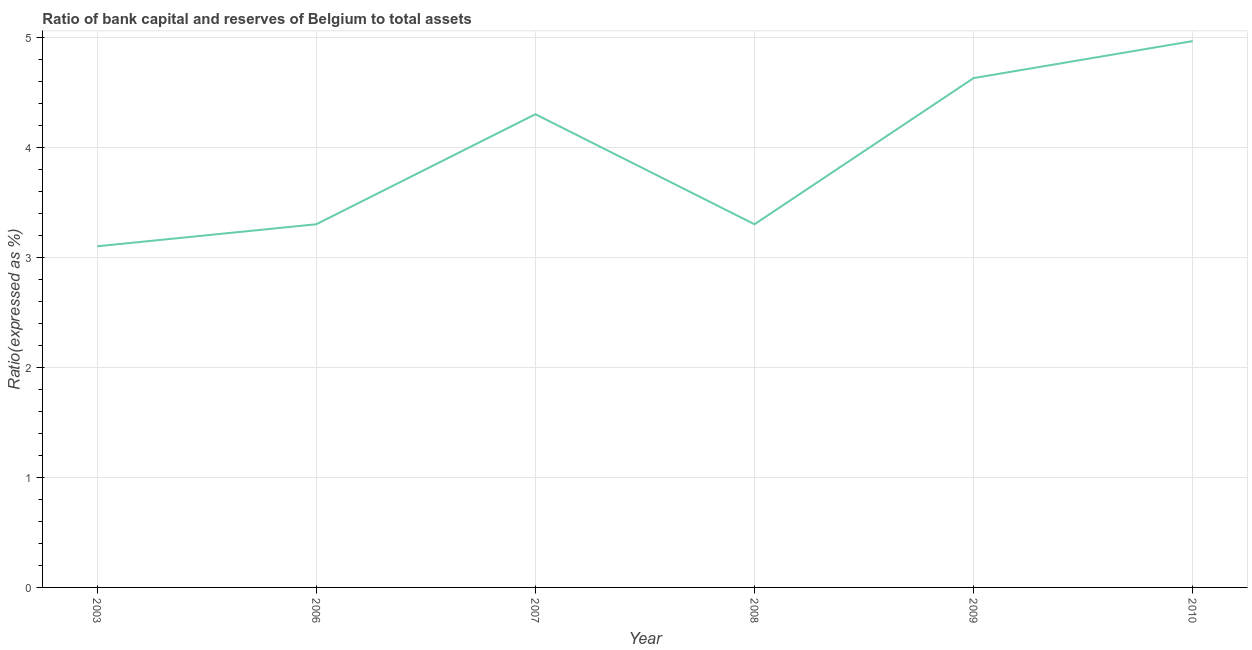Across all years, what is the maximum bank capital to assets ratio?
Offer a terse response. 4.96. Across all years, what is the minimum bank capital to assets ratio?
Your response must be concise. 3.1. What is the sum of the bank capital to assets ratio?
Offer a very short reply. 23.59. What is the difference between the bank capital to assets ratio in 2006 and 2008?
Make the answer very short. 0. What is the average bank capital to assets ratio per year?
Keep it short and to the point. 3.93. What is the median bank capital to assets ratio?
Your answer should be very brief. 3.8. In how many years, is the bank capital to assets ratio greater than 1.6 %?
Your answer should be compact. 6. What is the ratio of the bank capital to assets ratio in 2008 to that in 2010?
Your answer should be compact. 0.66. Is the bank capital to assets ratio in 2003 less than that in 2009?
Keep it short and to the point. Yes. What is the difference between the highest and the second highest bank capital to assets ratio?
Provide a succinct answer. 0.34. What is the difference between the highest and the lowest bank capital to assets ratio?
Make the answer very short. 1.86. Does the bank capital to assets ratio monotonically increase over the years?
Offer a very short reply. No. Does the graph contain any zero values?
Keep it short and to the point. No. Does the graph contain grids?
Make the answer very short. Yes. What is the title of the graph?
Your answer should be very brief. Ratio of bank capital and reserves of Belgium to total assets. What is the label or title of the Y-axis?
Ensure brevity in your answer.  Ratio(expressed as %). What is the Ratio(expressed as %) in 2008?
Keep it short and to the point. 3.3. What is the Ratio(expressed as %) in 2009?
Provide a succinct answer. 4.63. What is the Ratio(expressed as %) of 2010?
Offer a terse response. 4.96. What is the difference between the Ratio(expressed as %) in 2003 and 2006?
Ensure brevity in your answer.  -0.2. What is the difference between the Ratio(expressed as %) in 2003 and 2007?
Your answer should be compact. -1.2. What is the difference between the Ratio(expressed as %) in 2003 and 2009?
Provide a short and direct response. -1.53. What is the difference between the Ratio(expressed as %) in 2003 and 2010?
Make the answer very short. -1.86. What is the difference between the Ratio(expressed as %) in 2006 and 2007?
Your response must be concise. -1. What is the difference between the Ratio(expressed as %) in 2006 and 2009?
Keep it short and to the point. -1.33. What is the difference between the Ratio(expressed as %) in 2006 and 2010?
Your answer should be compact. -1.66. What is the difference between the Ratio(expressed as %) in 2007 and 2009?
Provide a short and direct response. -0.33. What is the difference between the Ratio(expressed as %) in 2007 and 2010?
Your answer should be compact. -0.66. What is the difference between the Ratio(expressed as %) in 2008 and 2009?
Keep it short and to the point. -1.33. What is the difference between the Ratio(expressed as %) in 2008 and 2010?
Offer a terse response. -1.66. What is the difference between the Ratio(expressed as %) in 2009 and 2010?
Provide a succinct answer. -0.34. What is the ratio of the Ratio(expressed as %) in 2003 to that in 2006?
Ensure brevity in your answer.  0.94. What is the ratio of the Ratio(expressed as %) in 2003 to that in 2007?
Keep it short and to the point. 0.72. What is the ratio of the Ratio(expressed as %) in 2003 to that in 2008?
Your response must be concise. 0.94. What is the ratio of the Ratio(expressed as %) in 2003 to that in 2009?
Your response must be concise. 0.67. What is the ratio of the Ratio(expressed as %) in 2003 to that in 2010?
Your response must be concise. 0.62. What is the ratio of the Ratio(expressed as %) in 2006 to that in 2007?
Offer a terse response. 0.77. What is the ratio of the Ratio(expressed as %) in 2006 to that in 2009?
Your answer should be compact. 0.71. What is the ratio of the Ratio(expressed as %) in 2006 to that in 2010?
Keep it short and to the point. 0.67. What is the ratio of the Ratio(expressed as %) in 2007 to that in 2008?
Your answer should be compact. 1.3. What is the ratio of the Ratio(expressed as %) in 2007 to that in 2009?
Provide a succinct answer. 0.93. What is the ratio of the Ratio(expressed as %) in 2007 to that in 2010?
Offer a very short reply. 0.87. What is the ratio of the Ratio(expressed as %) in 2008 to that in 2009?
Your answer should be very brief. 0.71. What is the ratio of the Ratio(expressed as %) in 2008 to that in 2010?
Ensure brevity in your answer.  0.67. What is the ratio of the Ratio(expressed as %) in 2009 to that in 2010?
Provide a succinct answer. 0.93. 